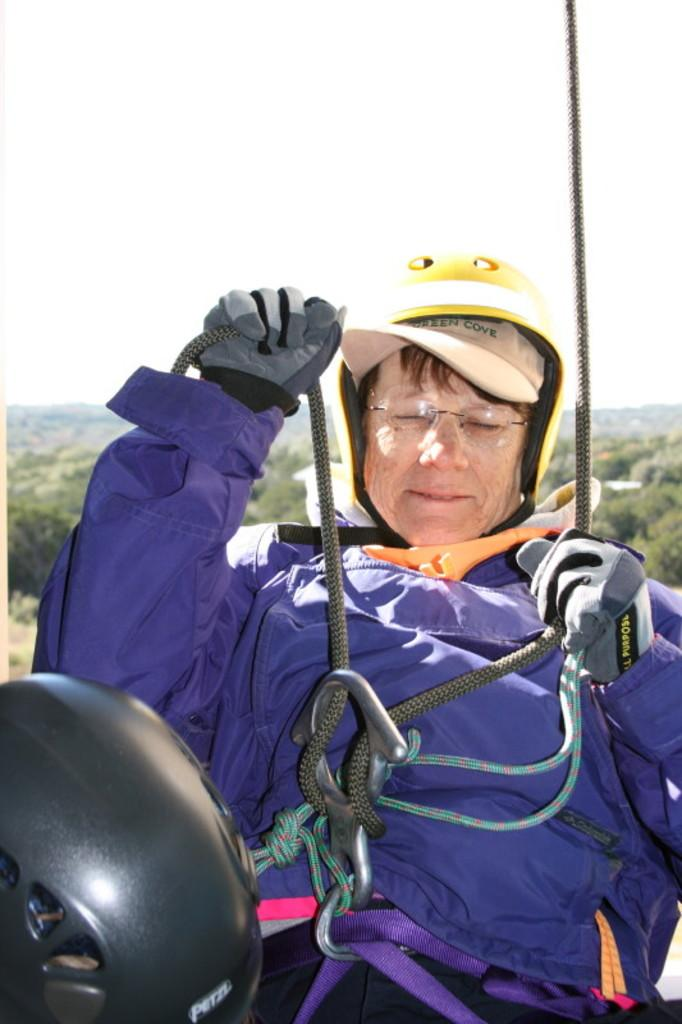What is the main subject of the image? There is a person in the image. What type of clothing is the person wearing? The person is wearing a jacket, a helmet, gloves, and glasses. What is the person holding in the image? The person is holding ropes. What can be seen in the background of the image? There are trees and the sky visible in the background of the image. Where is the cobweb located in the image? There is no cobweb present in the image. What type of pan is being used by the person in the image? There is no pan visible in the image; the person is holding ropes instead. 